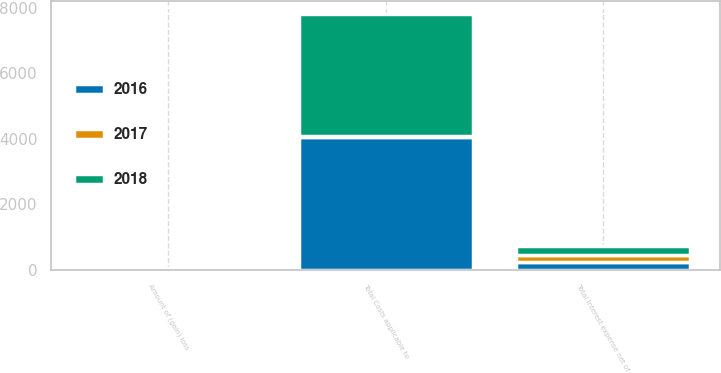Convert chart to OTSL. <chart><loc_0><loc_0><loc_500><loc_500><stacked_bar_chart><ecel><fcel>Total Costs applicable to<fcel>Amount of (gain) loss<fcel>Total Interest expense net of<nl><fcel>2017<fcel>29<fcel>10<fcel>207<nl><fcel>2016<fcel>4062<fcel>10<fcel>241<nl><fcel>2018<fcel>3738<fcel>33<fcel>273<nl></chart> 